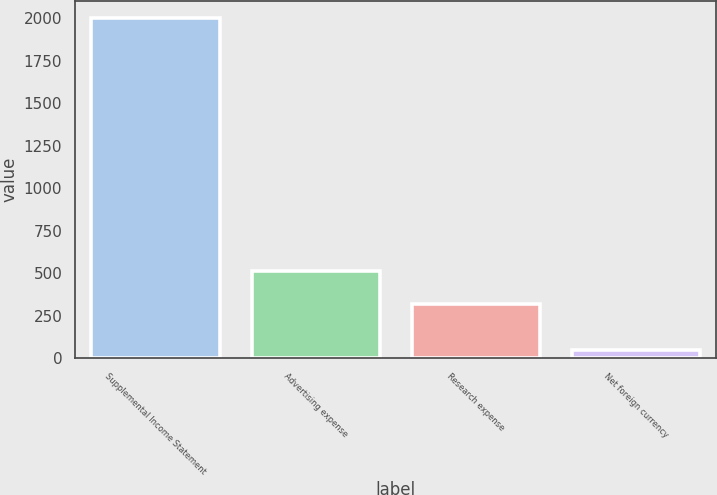<chart> <loc_0><loc_0><loc_500><loc_500><bar_chart><fcel>Supplemental Income Statement<fcel>Advertising expense<fcel>Research expense<fcel>Net foreign currency<nl><fcel>2005<fcel>515<fcel>319.5<fcel>50<nl></chart> 